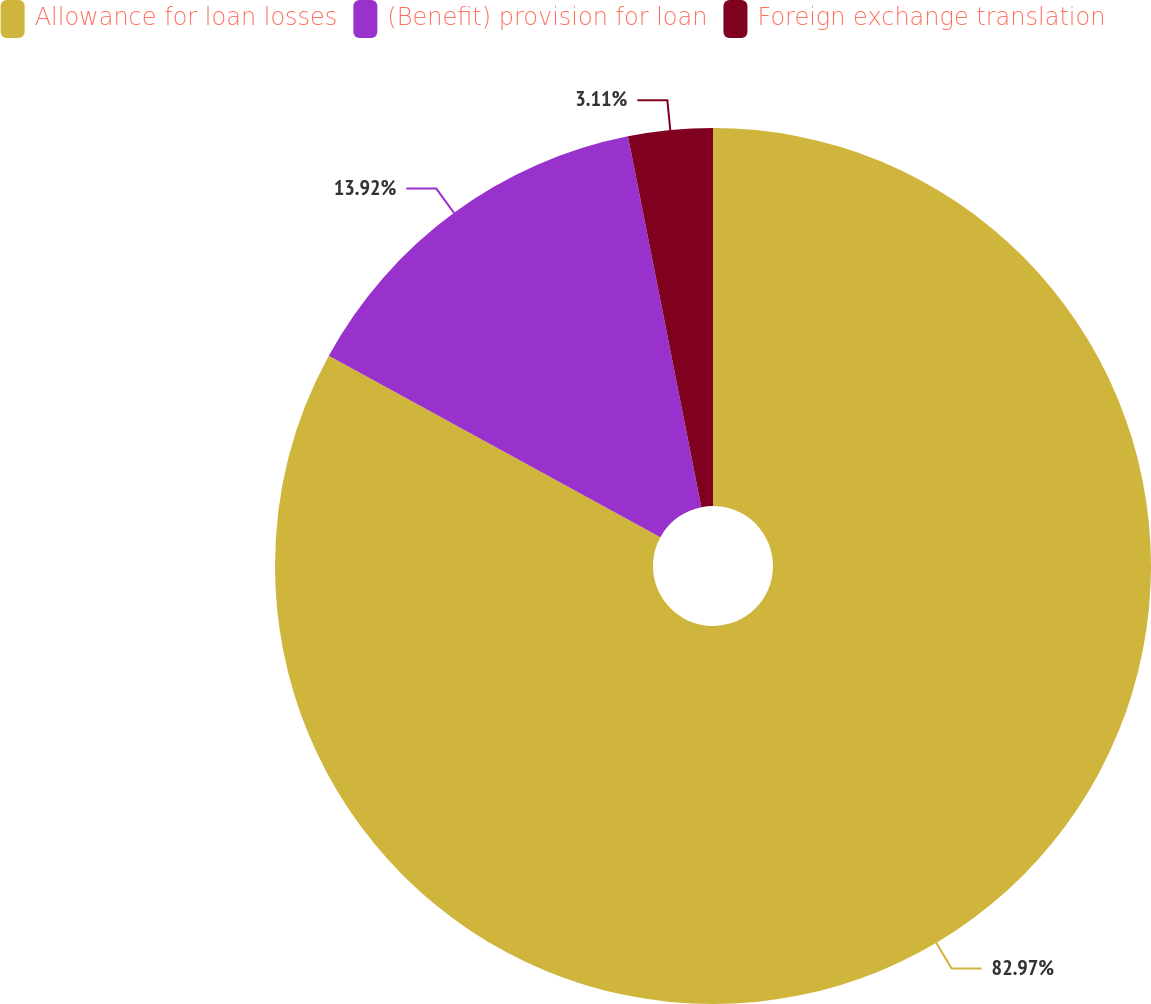Convert chart to OTSL. <chart><loc_0><loc_0><loc_500><loc_500><pie_chart><fcel>Allowance for loan losses<fcel>(Benefit) provision for loan<fcel>Foreign exchange translation<nl><fcel>82.97%<fcel>13.92%<fcel>3.11%<nl></chart> 